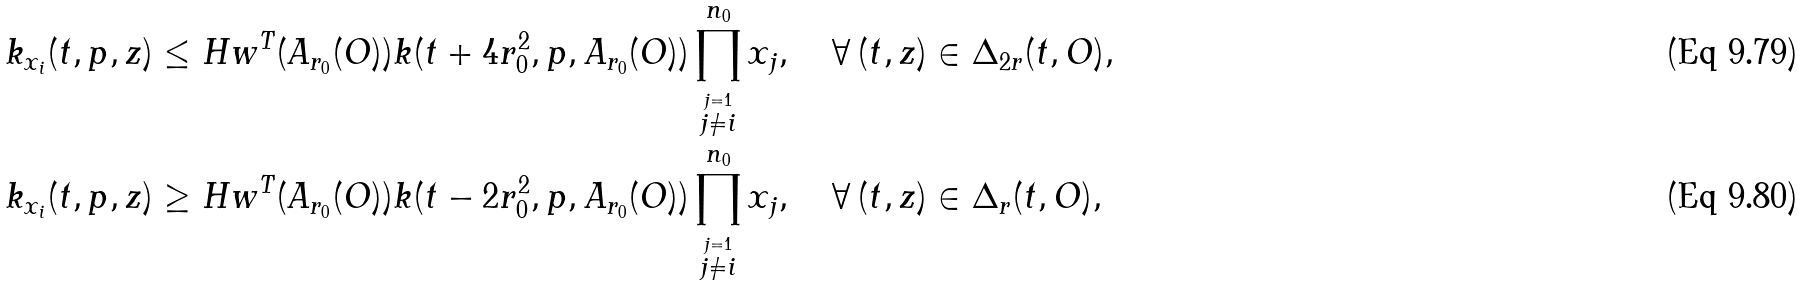Convert formula to latex. <formula><loc_0><loc_0><loc_500><loc_500>k _ { x _ { i } } ( t , p , z ) & \leq H w ^ { T } ( A _ { r _ { 0 } } ( O ) ) k ( t + 4 r _ { 0 } ^ { 2 } , p , A _ { r _ { 0 } } ( O ) ) \prod _ { \stackrel { j = 1 } { j \neq i } } ^ { n _ { 0 } } x _ { j } , \quad \forall \, ( t , z ) \in \Delta _ { 2 r } ( t , O ) , \\ k _ { x _ { i } } ( t , p , z ) & \geq H w ^ { T } ( A _ { r _ { 0 } } ( O ) ) k ( t - 2 r _ { 0 } ^ { 2 } , p , A _ { r _ { 0 } } ( O ) ) \prod _ { \stackrel { j = 1 } { j \neq i } } ^ { n _ { 0 } } x _ { j } , \quad \forall \, ( t , z ) \in \Delta _ { r } ( t , O ) ,</formula> 